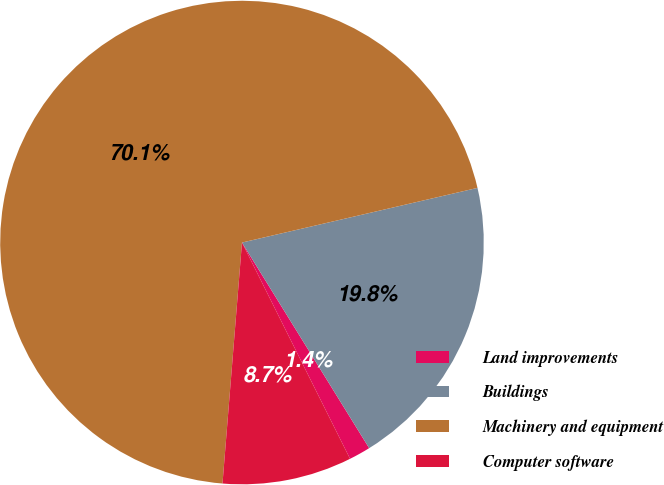Convert chart. <chart><loc_0><loc_0><loc_500><loc_500><pie_chart><fcel>Land improvements<fcel>Buildings<fcel>Machinery and equipment<fcel>Computer software<nl><fcel>1.44%<fcel>19.81%<fcel>70.08%<fcel>8.66%<nl></chart> 